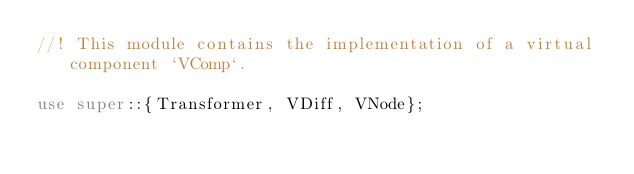<code> <loc_0><loc_0><loc_500><loc_500><_Rust_>//! This module contains the implementation of a virtual component `VComp`.

use super::{Transformer, VDiff, VNode};</code> 